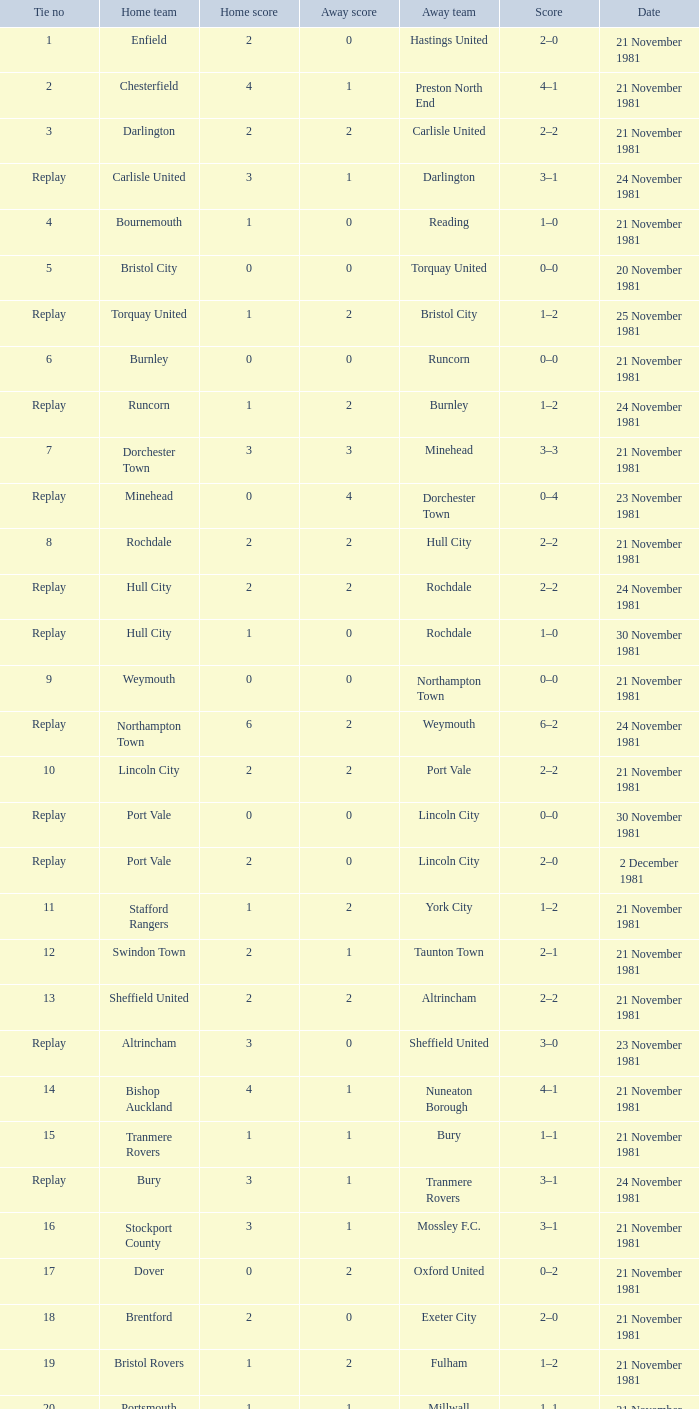What tie numeral does minehead have? Replay. 